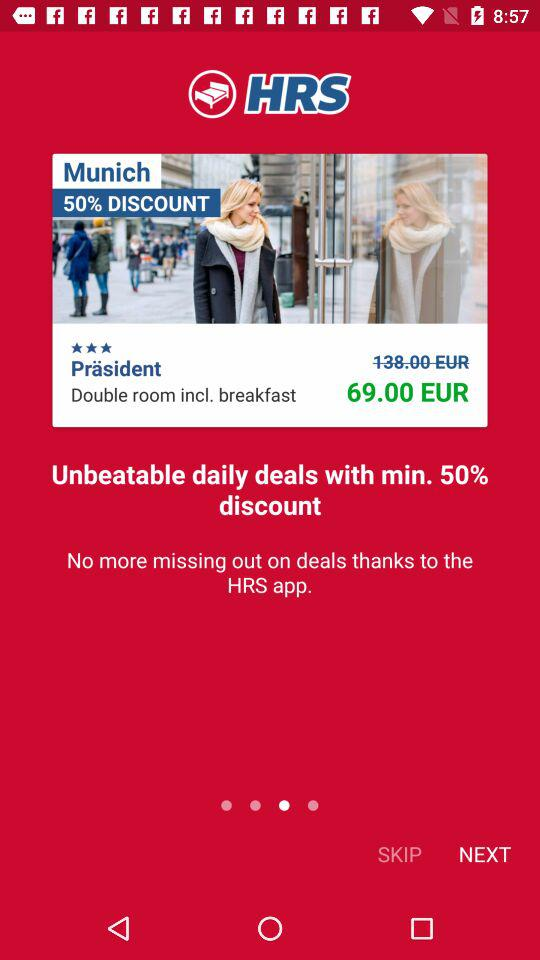How much is the discounted price of the hotel room?
Answer the question using a single word or phrase. 69.00 EUR 